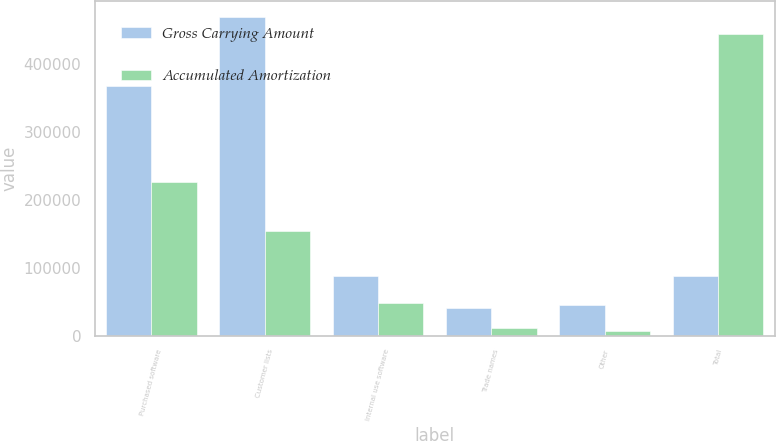Convert chart to OTSL. <chart><loc_0><loc_0><loc_500><loc_500><stacked_bar_chart><ecel><fcel>Purchased software<fcel>Customer lists<fcel>Internal use software<fcel>Trade names<fcel>Other<fcel>Total<nl><fcel>Gross Carrying Amount<fcel>368174<fcel>469353<fcel>87966<fcel>40583<fcel>44844<fcel>87966<nl><fcel>Accumulated Amortization<fcel>225754<fcel>153750<fcel>47325<fcel>11156<fcel>6888<fcel>444873<nl></chart> 